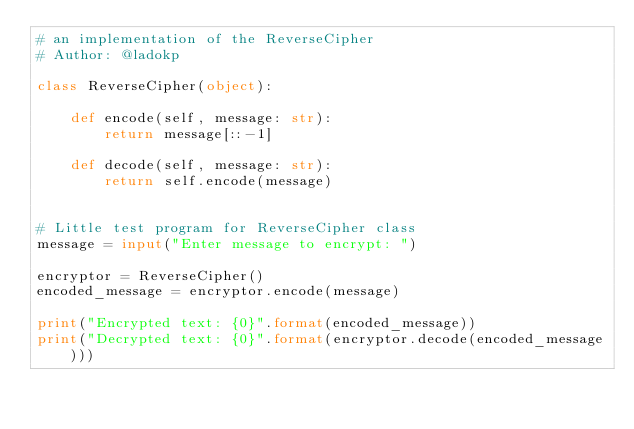<code> <loc_0><loc_0><loc_500><loc_500><_Python_># an implementation of the ReverseCipher
# Author: @ladokp

class ReverseCipher(object):

    def encode(self, message: str):
        return message[::-1]

    def decode(self, message: str):
        return self.encode(message)


# Little test program for ReverseCipher class
message = input("Enter message to encrypt: ")

encryptor = ReverseCipher()
encoded_message = encryptor.encode(message)

print("Encrypted text: {0}".format(encoded_message))
print("Decrypted text: {0}".format(encryptor.decode(encoded_message)))</code> 